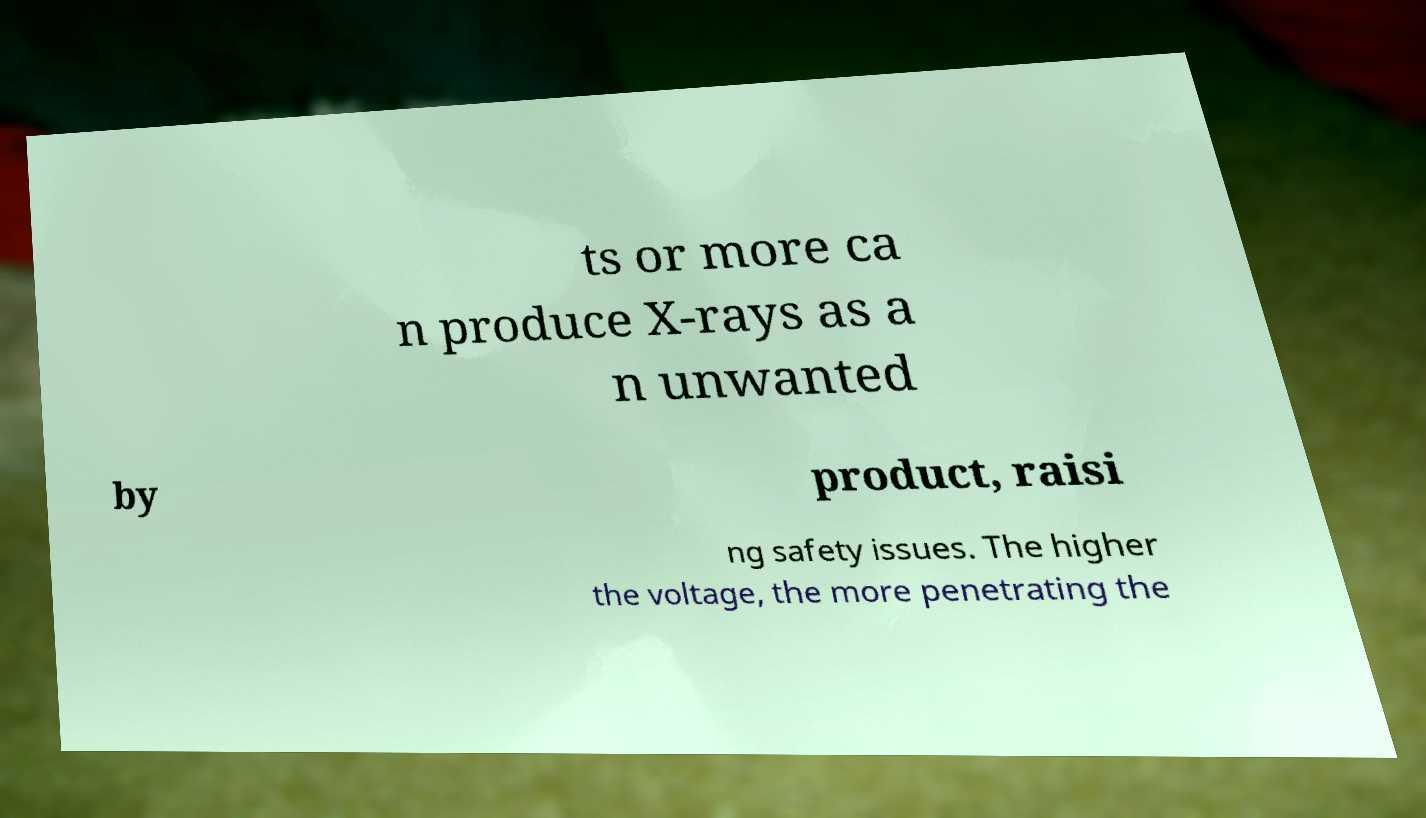What messages or text are displayed in this image? I need them in a readable, typed format. ts or more ca n produce X-rays as a n unwanted by product, raisi ng safety issues. The higher the voltage, the more penetrating the 